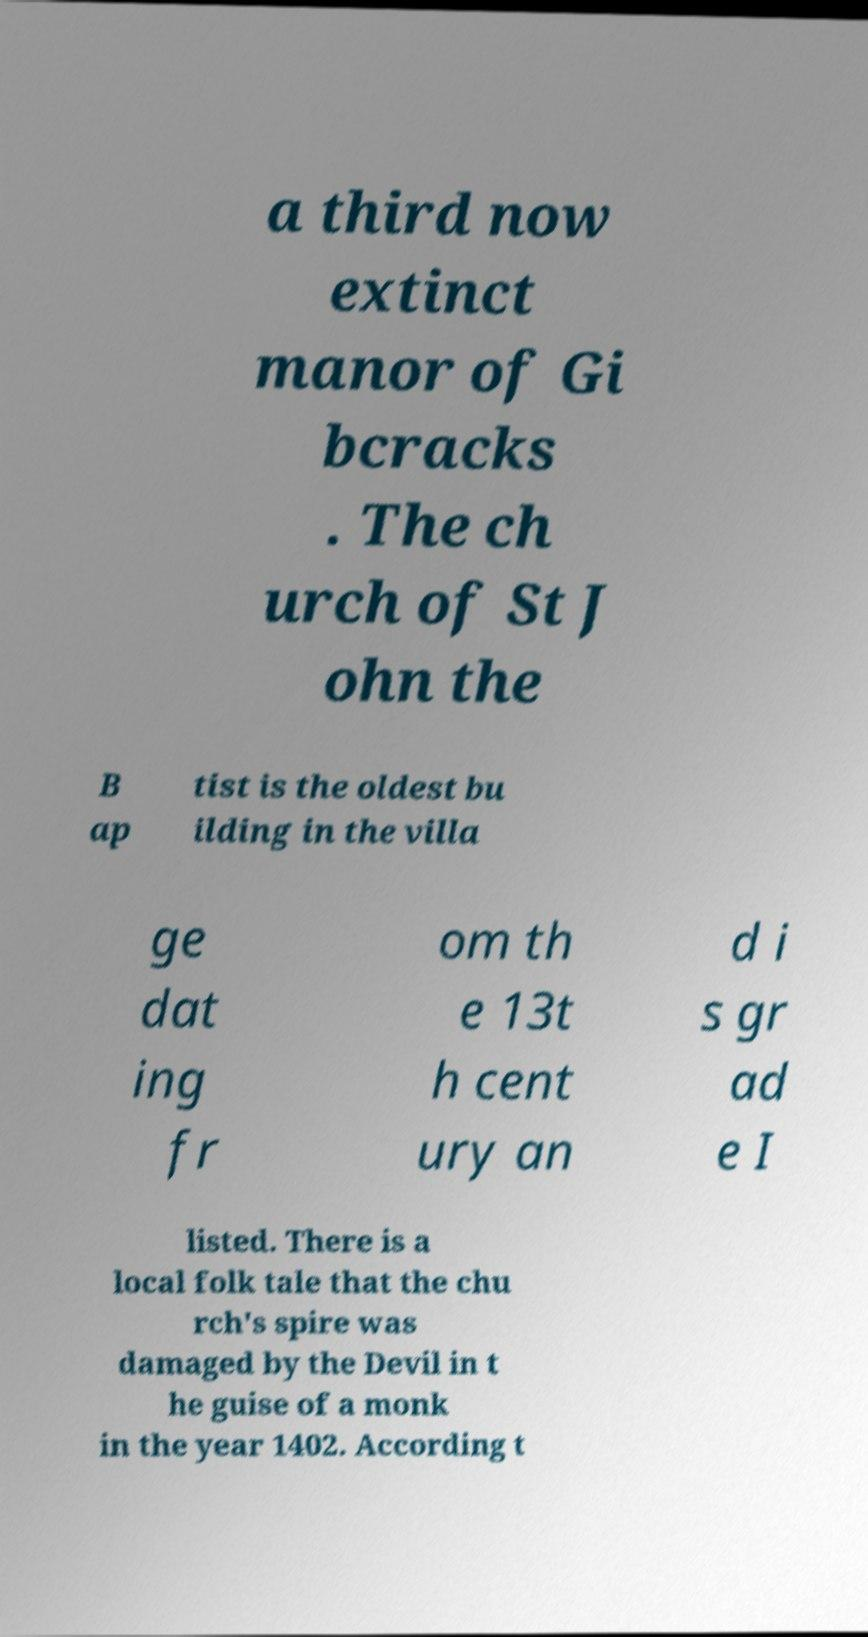I need the written content from this picture converted into text. Can you do that? a third now extinct manor of Gi bcracks . The ch urch of St J ohn the B ap tist is the oldest bu ilding in the villa ge dat ing fr om th e 13t h cent ury an d i s gr ad e I listed. There is a local folk tale that the chu rch's spire was damaged by the Devil in t he guise of a monk in the year 1402. According t 